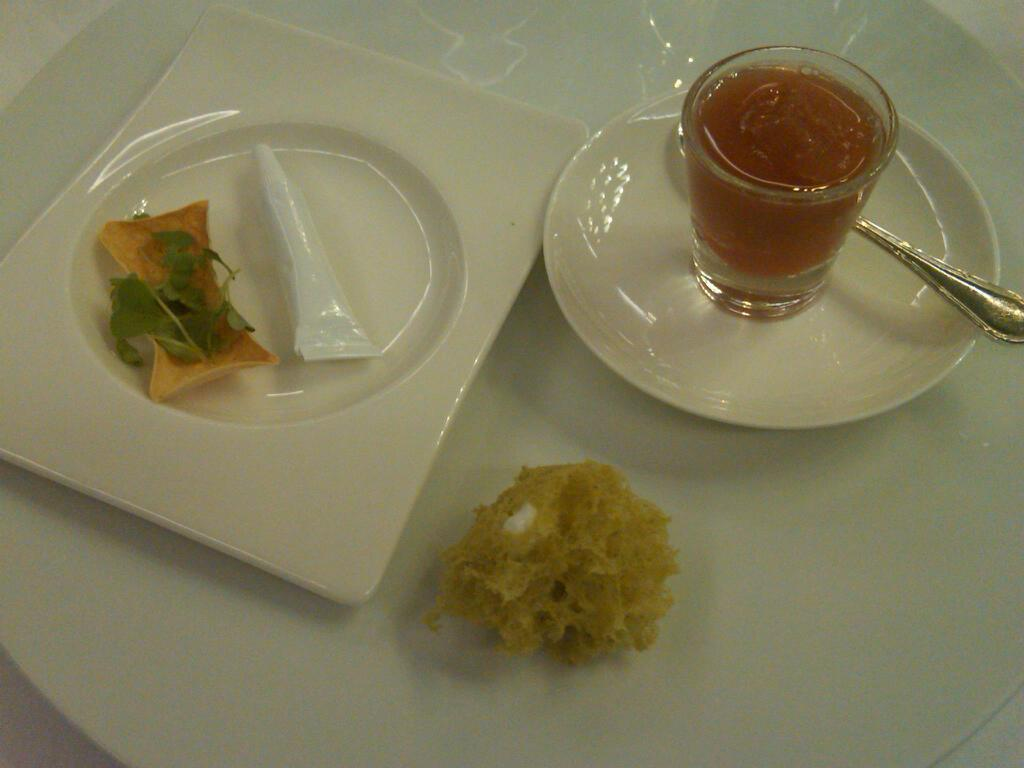What objects can be seen on the plates in the image? In one plate, there is a spoon and a glass, while in other plates, there are food items. What is the glass containing? The glass contains some liquid. How many children are playing with the cow in the image? There are no children or cows present in the image. 